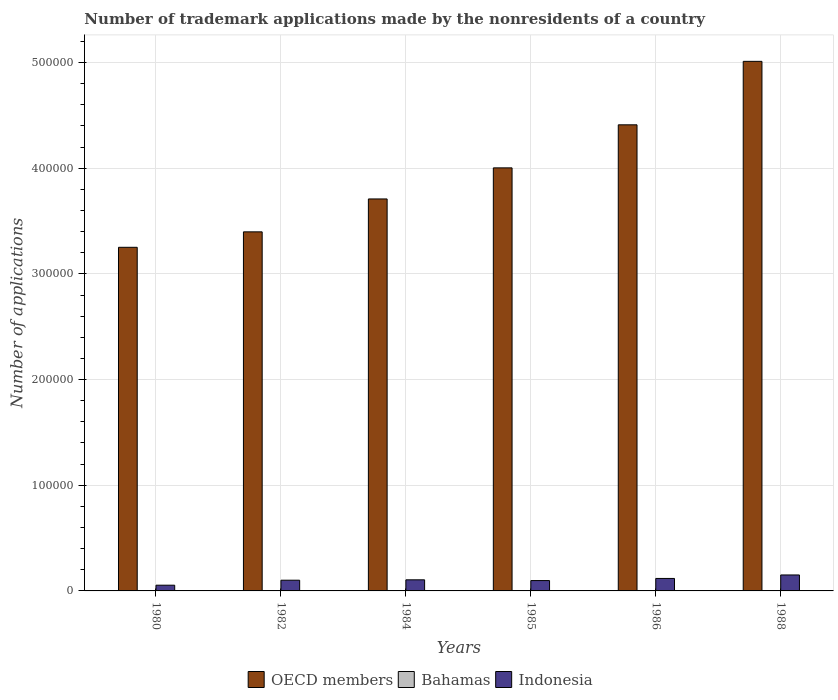How many groups of bars are there?
Your response must be concise. 6. Are the number of bars on each tick of the X-axis equal?
Offer a very short reply. Yes. In how many cases, is the number of bars for a given year not equal to the number of legend labels?
Your response must be concise. 0. What is the number of trademark applications made by the nonresidents in Indonesia in 1985?
Offer a very short reply. 9802. Across all years, what is the maximum number of trademark applications made by the nonresidents in OECD members?
Ensure brevity in your answer.  5.01e+05. Across all years, what is the minimum number of trademark applications made by the nonresidents in OECD members?
Provide a succinct answer. 3.25e+05. In which year was the number of trademark applications made by the nonresidents in Bahamas minimum?
Provide a short and direct response. 1980. What is the total number of trademark applications made by the nonresidents in Bahamas in the graph?
Your response must be concise. 249. What is the difference between the number of trademark applications made by the nonresidents in Indonesia in 1984 and that in 1988?
Offer a very short reply. -4599. What is the difference between the number of trademark applications made by the nonresidents in Indonesia in 1986 and the number of trademark applications made by the nonresidents in Bahamas in 1988?
Your answer should be compact. 1.17e+04. What is the average number of trademark applications made by the nonresidents in Bahamas per year?
Ensure brevity in your answer.  41.5. In the year 1982, what is the difference between the number of trademark applications made by the nonresidents in Bahamas and number of trademark applications made by the nonresidents in OECD members?
Offer a terse response. -3.40e+05. What is the ratio of the number of trademark applications made by the nonresidents in OECD members in 1982 to that in 1985?
Your answer should be compact. 0.85. Is the number of trademark applications made by the nonresidents in Indonesia in 1985 less than that in 1986?
Make the answer very short. Yes. Is the difference between the number of trademark applications made by the nonresidents in Bahamas in 1982 and 1984 greater than the difference between the number of trademark applications made by the nonresidents in OECD members in 1982 and 1984?
Provide a succinct answer. Yes. What is the difference between the highest and the second highest number of trademark applications made by the nonresidents in OECD members?
Ensure brevity in your answer.  6.01e+04. What is the difference between the highest and the lowest number of trademark applications made by the nonresidents in Bahamas?
Offer a very short reply. 50. In how many years, is the number of trademark applications made by the nonresidents in OECD members greater than the average number of trademark applications made by the nonresidents in OECD members taken over all years?
Make the answer very short. 3. What does the 1st bar from the left in 1982 represents?
Offer a terse response. OECD members. What does the 1st bar from the right in 1988 represents?
Keep it short and to the point. Indonesia. How many bars are there?
Your response must be concise. 18. How many years are there in the graph?
Provide a succinct answer. 6. Are the values on the major ticks of Y-axis written in scientific E-notation?
Make the answer very short. No. Where does the legend appear in the graph?
Your answer should be compact. Bottom center. What is the title of the graph?
Keep it short and to the point. Number of trademark applications made by the nonresidents of a country. Does "Haiti" appear as one of the legend labels in the graph?
Ensure brevity in your answer.  No. What is the label or title of the Y-axis?
Offer a very short reply. Number of applications. What is the Number of applications in OECD members in 1980?
Ensure brevity in your answer.  3.25e+05. What is the Number of applications in Bahamas in 1980?
Offer a terse response. 21. What is the Number of applications of Indonesia in 1980?
Your answer should be compact. 5425. What is the Number of applications in OECD members in 1982?
Provide a short and direct response. 3.40e+05. What is the Number of applications of Indonesia in 1982?
Offer a terse response. 1.01e+04. What is the Number of applications of OECD members in 1984?
Provide a short and direct response. 3.71e+05. What is the Number of applications of Indonesia in 1984?
Your answer should be very brief. 1.05e+04. What is the Number of applications of OECD members in 1985?
Provide a succinct answer. 4.00e+05. What is the Number of applications in Indonesia in 1985?
Your answer should be very brief. 9802. What is the Number of applications of OECD members in 1986?
Your answer should be compact. 4.41e+05. What is the Number of applications of Indonesia in 1986?
Provide a short and direct response. 1.18e+04. What is the Number of applications of OECD members in 1988?
Provide a succinct answer. 5.01e+05. What is the Number of applications in Indonesia in 1988?
Make the answer very short. 1.51e+04. Across all years, what is the maximum Number of applications of OECD members?
Offer a terse response. 5.01e+05. Across all years, what is the maximum Number of applications of Indonesia?
Your answer should be compact. 1.51e+04. Across all years, what is the minimum Number of applications in OECD members?
Offer a very short reply. 3.25e+05. Across all years, what is the minimum Number of applications of Indonesia?
Your response must be concise. 5425. What is the total Number of applications in OECD members in the graph?
Give a very brief answer. 2.38e+06. What is the total Number of applications of Bahamas in the graph?
Give a very brief answer. 249. What is the total Number of applications of Indonesia in the graph?
Your answer should be very brief. 6.28e+04. What is the difference between the Number of applications in OECD members in 1980 and that in 1982?
Offer a very short reply. -1.46e+04. What is the difference between the Number of applications in Indonesia in 1980 and that in 1982?
Keep it short and to the point. -4704. What is the difference between the Number of applications in OECD members in 1980 and that in 1984?
Offer a terse response. -4.58e+04. What is the difference between the Number of applications in Indonesia in 1980 and that in 1984?
Ensure brevity in your answer.  -5085. What is the difference between the Number of applications of OECD members in 1980 and that in 1985?
Ensure brevity in your answer.  -7.52e+04. What is the difference between the Number of applications in Indonesia in 1980 and that in 1985?
Offer a terse response. -4377. What is the difference between the Number of applications in OECD members in 1980 and that in 1986?
Keep it short and to the point. -1.16e+05. What is the difference between the Number of applications of Bahamas in 1980 and that in 1986?
Provide a succinct answer. -39. What is the difference between the Number of applications of Indonesia in 1980 and that in 1986?
Make the answer very short. -6382. What is the difference between the Number of applications in OECD members in 1980 and that in 1988?
Keep it short and to the point. -1.76e+05. What is the difference between the Number of applications in Bahamas in 1980 and that in 1988?
Your response must be concise. -50. What is the difference between the Number of applications of Indonesia in 1980 and that in 1988?
Give a very brief answer. -9684. What is the difference between the Number of applications in OECD members in 1982 and that in 1984?
Your answer should be very brief. -3.11e+04. What is the difference between the Number of applications of Bahamas in 1982 and that in 1984?
Your response must be concise. 9. What is the difference between the Number of applications of Indonesia in 1982 and that in 1984?
Make the answer very short. -381. What is the difference between the Number of applications of OECD members in 1982 and that in 1985?
Your response must be concise. -6.06e+04. What is the difference between the Number of applications of Indonesia in 1982 and that in 1985?
Your answer should be compact. 327. What is the difference between the Number of applications of OECD members in 1982 and that in 1986?
Offer a terse response. -1.01e+05. What is the difference between the Number of applications of Bahamas in 1982 and that in 1986?
Provide a succinct answer. -27. What is the difference between the Number of applications of Indonesia in 1982 and that in 1986?
Your response must be concise. -1678. What is the difference between the Number of applications in OECD members in 1982 and that in 1988?
Offer a terse response. -1.61e+05. What is the difference between the Number of applications of Bahamas in 1982 and that in 1988?
Ensure brevity in your answer.  -38. What is the difference between the Number of applications in Indonesia in 1982 and that in 1988?
Give a very brief answer. -4980. What is the difference between the Number of applications in OECD members in 1984 and that in 1985?
Provide a short and direct response. -2.94e+04. What is the difference between the Number of applications of Indonesia in 1984 and that in 1985?
Offer a very short reply. 708. What is the difference between the Number of applications in OECD members in 1984 and that in 1986?
Your answer should be compact. -7.02e+04. What is the difference between the Number of applications of Bahamas in 1984 and that in 1986?
Offer a terse response. -36. What is the difference between the Number of applications of Indonesia in 1984 and that in 1986?
Your response must be concise. -1297. What is the difference between the Number of applications of OECD members in 1984 and that in 1988?
Keep it short and to the point. -1.30e+05. What is the difference between the Number of applications in Bahamas in 1984 and that in 1988?
Your answer should be very brief. -47. What is the difference between the Number of applications in Indonesia in 1984 and that in 1988?
Offer a very short reply. -4599. What is the difference between the Number of applications in OECD members in 1985 and that in 1986?
Give a very brief answer. -4.07e+04. What is the difference between the Number of applications of Indonesia in 1985 and that in 1986?
Offer a terse response. -2005. What is the difference between the Number of applications of OECD members in 1985 and that in 1988?
Make the answer very short. -1.01e+05. What is the difference between the Number of applications in Bahamas in 1985 and that in 1988?
Provide a short and direct response. -31. What is the difference between the Number of applications of Indonesia in 1985 and that in 1988?
Ensure brevity in your answer.  -5307. What is the difference between the Number of applications of OECD members in 1986 and that in 1988?
Give a very brief answer. -6.01e+04. What is the difference between the Number of applications in Bahamas in 1986 and that in 1988?
Give a very brief answer. -11. What is the difference between the Number of applications of Indonesia in 1986 and that in 1988?
Keep it short and to the point. -3302. What is the difference between the Number of applications in OECD members in 1980 and the Number of applications in Bahamas in 1982?
Give a very brief answer. 3.25e+05. What is the difference between the Number of applications of OECD members in 1980 and the Number of applications of Indonesia in 1982?
Ensure brevity in your answer.  3.15e+05. What is the difference between the Number of applications in Bahamas in 1980 and the Number of applications in Indonesia in 1982?
Give a very brief answer. -1.01e+04. What is the difference between the Number of applications of OECD members in 1980 and the Number of applications of Bahamas in 1984?
Your answer should be very brief. 3.25e+05. What is the difference between the Number of applications in OECD members in 1980 and the Number of applications in Indonesia in 1984?
Your answer should be very brief. 3.15e+05. What is the difference between the Number of applications of Bahamas in 1980 and the Number of applications of Indonesia in 1984?
Your answer should be very brief. -1.05e+04. What is the difference between the Number of applications in OECD members in 1980 and the Number of applications in Bahamas in 1985?
Offer a very short reply. 3.25e+05. What is the difference between the Number of applications in OECD members in 1980 and the Number of applications in Indonesia in 1985?
Your answer should be compact. 3.15e+05. What is the difference between the Number of applications of Bahamas in 1980 and the Number of applications of Indonesia in 1985?
Ensure brevity in your answer.  -9781. What is the difference between the Number of applications of OECD members in 1980 and the Number of applications of Bahamas in 1986?
Provide a succinct answer. 3.25e+05. What is the difference between the Number of applications of OECD members in 1980 and the Number of applications of Indonesia in 1986?
Offer a very short reply. 3.13e+05. What is the difference between the Number of applications of Bahamas in 1980 and the Number of applications of Indonesia in 1986?
Make the answer very short. -1.18e+04. What is the difference between the Number of applications in OECD members in 1980 and the Number of applications in Bahamas in 1988?
Provide a succinct answer. 3.25e+05. What is the difference between the Number of applications in OECD members in 1980 and the Number of applications in Indonesia in 1988?
Offer a very short reply. 3.10e+05. What is the difference between the Number of applications of Bahamas in 1980 and the Number of applications of Indonesia in 1988?
Offer a terse response. -1.51e+04. What is the difference between the Number of applications in OECD members in 1982 and the Number of applications in Bahamas in 1984?
Give a very brief answer. 3.40e+05. What is the difference between the Number of applications in OECD members in 1982 and the Number of applications in Indonesia in 1984?
Offer a terse response. 3.29e+05. What is the difference between the Number of applications of Bahamas in 1982 and the Number of applications of Indonesia in 1984?
Offer a very short reply. -1.05e+04. What is the difference between the Number of applications in OECD members in 1982 and the Number of applications in Bahamas in 1985?
Your answer should be compact. 3.40e+05. What is the difference between the Number of applications in OECD members in 1982 and the Number of applications in Indonesia in 1985?
Your answer should be very brief. 3.30e+05. What is the difference between the Number of applications in Bahamas in 1982 and the Number of applications in Indonesia in 1985?
Keep it short and to the point. -9769. What is the difference between the Number of applications of OECD members in 1982 and the Number of applications of Bahamas in 1986?
Provide a succinct answer. 3.40e+05. What is the difference between the Number of applications of OECD members in 1982 and the Number of applications of Indonesia in 1986?
Provide a succinct answer. 3.28e+05. What is the difference between the Number of applications in Bahamas in 1982 and the Number of applications in Indonesia in 1986?
Provide a short and direct response. -1.18e+04. What is the difference between the Number of applications in OECD members in 1982 and the Number of applications in Bahamas in 1988?
Offer a terse response. 3.40e+05. What is the difference between the Number of applications of OECD members in 1982 and the Number of applications of Indonesia in 1988?
Provide a succinct answer. 3.25e+05. What is the difference between the Number of applications in Bahamas in 1982 and the Number of applications in Indonesia in 1988?
Ensure brevity in your answer.  -1.51e+04. What is the difference between the Number of applications of OECD members in 1984 and the Number of applications of Bahamas in 1985?
Give a very brief answer. 3.71e+05. What is the difference between the Number of applications of OECD members in 1984 and the Number of applications of Indonesia in 1985?
Provide a short and direct response. 3.61e+05. What is the difference between the Number of applications of Bahamas in 1984 and the Number of applications of Indonesia in 1985?
Provide a short and direct response. -9778. What is the difference between the Number of applications in OECD members in 1984 and the Number of applications in Bahamas in 1986?
Your answer should be very brief. 3.71e+05. What is the difference between the Number of applications of OECD members in 1984 and the Number of applications of Indonesia in 1986?
Offer a terse response. 3.59e+05. What is the difference between the Number of applications of Bahamas in 1984 and the Number of applications of Indonesia in 1986?
Your answer should be compact. -1.18e+04. What is the difference between the Number of applications of OECD members in 1984 and the Number of applications of Bahamas in 1988?
Ensure brevity in your answer.  3.71e+05. What is the difference between the Number of applications of OECD members in 1984 and the Number of applications of Indonesia in 1988?
Offer a very short reply. 3.56e+05. What is the difference between the Number of applications of Bahamas in 1984 and the Number of applications of Indonesia in 1988?
Offer a very short reply. -1.51e+04. What is the difference between the Number of applications in OECD members in 1985 and the Number of applications in Bahamas in 1986?
Provide a short and direct response. 4.00e+05. What is the difference between the Number of applications in OECD members in 1985 and the Number of applications in Indonesia in 1986?
Make the answer very short. 3.89e+05. What is the difference between the Number of applications of Bahamas in 1985 and the Number of applications of Indonesia in 1986?
Your answer should be very brief. -1.18e+04. What is the difference between the Number of applications of OECD members in 1985 and the Number of applications of Bahamas in 1988?
Provide a short and direct response. 4.00e+05. What is the difference between the Number of applications of OECD members in 1985 and the Number of applications of Indonesia in 1988?
Keep it short and to the point. 3.85e+05. What is the difference between the Number of applications in Bahamas in 1985 and the Number of applications in Indonesia in 1988?
Make the answer very short. -1.51e+04. What is the difference between the Number of applications in OECD members in 1986 and the Number of applications in Bahamas in 1988?
Your answer should be very brief. 4.41e+05. What is the difference between the Number of applications in OECD members in 1986 and the Number of applications in Indonesia in 1988?
Offer a terse response. 4.26e+05. What is the difference between the Number of applications of Bahamas in 1986 and the Number of applications of Indonesia in 1988?
Offer a very short reply. -1.50e+04. What is the average Number of applications in OECD members per year?
Offer a terse response. 3.96e+05. What is the average Number of applications of Bahamas per year?
Your answer should be compact. 41.5. What is the average Number of applications in Indonesia per year?
Offer a terse response. 1.05e+04. In the year 1980, what is the difference between the Number of applications of OECD members and Number of applications of Bahamas?
Give a very brief answer. 3.25e+05. In the year 1980, what is the difference between the Number of applications of OECD members and Number of applications of Indonesia?
Provide a short and direct response. 3.20e+05. In the year 1980, what is the difference between the Number of applications in Bahamas and Number of applications in Indonesia?
Provide a short and direct response. -5404. In the year 1982, what is the difference between the Number of applications of OECD members and Number of applications of Bahamas?
Make the answer very short. 3.40e+05. In the year 1982, what is the difference between the Number of applications of OECD members and Number of applications of Indonesia?
Give a very brief answer. 3.30e+05. In the year 1982, what is the difference between the Number of applications of Bahamas and Number of applications of Indonesia?
Your response must be concise. -1.01e+04. In the year 1984, what is the difference between the Number of applications of OECD members and Number of applications of Bahamas?
Keep it short and to the point. 3.71e+05. In the year 1984, what is the difference between the Number of applications of OECD members and Number of applications of Indonesia?
Provide a short and direct response. 3.60e+05. In the year 1984, what is the difference between the Number of applications in Bahamas and Number of applications in Indonesia?
Your response must be concise. -1.05e+04. In the year 1985, what is the difference between the Number of applications of OECD members and Number of applications of Bahamas?
Keep it short and to the point. 4.00e+05. In the year 1985, what is the difference between the Number of applications in OECD members and Number of applications in Indonesia?
Your answer should be compact. 3.91e+05. In the year 1985, what is the difference between the Number of applications in Bahamas and Number of applications in Indonesia?
Provide a short and direct response. -9762. In the year 1986, what is the difference between the Number of applications of OECD members and Number of applications of Bahamas?
Give a very brief answer. 4.41e+05. In the year 1986, what is the difference between the Number of applications in OECD members and Number of applications in Indonesia?
Provide a short and direct response. 4.29e+05. In the year 1986, what is the difference between the Number of applications in Bahamas and Number of applications in Indonesia?
Offer a very short reply. -1.17e+04. In the year 1988, what is the difference between the Number of applications of OECD members and Number of applications of Bahamas?
Provide a short and direct response. 5.01e+05. In the year 1988, what is the difference between the Number of applications in OECD members and Number of applications in Indonesia?
Keep it short and to the point. 4.86e+05. In the year 1988, what is the difference between the Number of applications in Bahamas and Number of applications in Indonesia?
Offer a very short reply. -1.50e+04. What is the ratio of the Number of applications in OECD members in 1980 to that in 1982?
Keep it short and to the point. 0.96. What is the ratio of the Number of applications in Bahamas in 1980 to that in 1982?
Your answer should be compact. 0.64. What is the ratio of the Number of applications of Indonesia in 1980 to that in 1982?
Keep it short and to the point. 0.54. What is the ratio of the Number of applications in OECD members in 1980 to that in 1984?
Your answer should be compact. 0.88. What is the ratio of the Number of applications in Bahamas in 1980 to that in 1984?
Give a very brief answer. 0.88. What is the ratio of the Number of applications of Indonesia in 1980 to that in 1984?
Offer a very short reply. 0.52. What is the ratio of the Number of applications in OECD members in 1980 to that in 1985?
Ensure brevity in your answer.  0.81. What is the ratio of the Number of applications in Bahamas in 1980 to that in 1985?
Offer a terse response. 0.53. What is the ratio of the Number of applications of Indonesia in 1980 to that in 1985?
Offer a very short reply. 0.55. What is the ratio of the Number of applications of OECD members in 1980 to that in 1986?
Provide a short and direct response. 0.74. What is the ratio of the Number of applications in Bahamas in 1980 to that in 1986?
Keep it short and to the point. 0.35. What is the ratio of the Number of applications in Indonesia in 1980 to that in 1986?
Provide a succinct answer. 0.46. What is the ratio of the Number of applications in OECD members in 1980 to that in 1988?
Provide a short and direct response. 0.65. What is the ratio of the Number of applications in Bahamas in 1980 to that in 1988?
Provide a short and direct response. 0.3. What is the ratio of the Number of applications in Indonesia in 1980 to that in 1988?
Give a very brief answer. 0.36. What is the ratio of the Number of applications of OECD members in 1982 to that in 1984?
Provide a succinct answer. 0.92. What is the ratio of the Number of applications in Bahamas in 1982 to that in 1984?
Keep it short and to the point. 1.38. What is the ratio of the Number of applications of Indonesia in 1982 to that in 1984?
Give a very brief answer. 0.96. What is the ratio of the Number of applications of OECD members in 1982 to that in 1985?
Provide a short and direct response. 0.85. What is the ratio of the Number of applications in Bahamas in 1982 to that in 1985?
Provide a succinct answer. 0.82. What is the ratio of the Number of applications in Indonesia in 1982 to that in 1985?
Offer a very short reply. 1.03. What is the ratio of the Number of applications of OECD members in 1982 to that in 1986?
Keep it short and to the point. 0.77. What is the ratio of the Number of applications in Bahamas in 1982 to that in 1986?
Keep it short and to the point. 0.55. What is the ratio of the Number of applications in Indonesia in 1982 to that in 1986?
Provide a short and direct response. 0.86. What is the ratio of the Number of applications of OECD members in 1982 to that in 1988?
Offer a very short reply. 0.68. What is the ratio of the Number of applications in Bahamas in 1982 to that in 1988?
Ensure brevity in your answer.  0.46. What is the ratio of the Number of applications of Indonesia in 1982 to that in 1988?
Your answer should be compact. 0.67. What is the ratio of the Number of applications in OECD members in 1984 to that in 1985?
Provide a succinct answer. 0.93. What is the ratio of the Number of applications in Bahamas in 1984 to that in 1985?
Make the answer very short. 0.6. What is the ratio of the Number of applications of Indonesia in 1984 to that in 1985?
Your response must be concise. 1.07. What is the ratio of the Number of applications of OECD members in 1984 to that in 1986?
Ensure brevity in your answer.  0.84. What is the ratio of the Number of applications of Indonesia in 1984 to that in 1986?
Provide a succinct answer. 0.89. What is the ratio of the Number of applications of OECD members in 1984 to that in 1988?
Your answer should be compact. 0.74. What is the ratio of the Number of applications of Bahamas in 1984 to that in 1988?
Offer a very short reply. 0.34. What is the ratio of the Number of applications in Indonesia in 1984 to that in 1988?
Your response must be concise. 0.7. What is the ratio of the Number of applications in OECD members in 1985 to that in 1986?
Your answer should be compact. 0.91. What is the ratio of the Number of applications of Indonesia in 1985 to that in 1986?
Your answer should be compact. 0.83. What is the ratio of the Number of applications of OECD members in 1985 to that in 1988?
Offer a terse response. 0.8. What is the ratio of the Number of applications in Bahamas in 1985 to that in 1988?
Keep it short and to the point. 0.56. What is the ratio of the Number of applications in Indonesia in 1985 to that in 1988?
Provide a short and direct response. 0.65. What is the ratio of the Number of applications of OECD members in 1986 to that in 1988?
Your answer should be very brief. 0.88. What is the ratio of the Number of applications of Bahamas in 1986 to that in 1988?
Ensure brevity in your answer.  0.85. What is the ratio of the Number of applications in Indonesia in 1986 to that in 1988?
Offer a terse response. 0.78. What is the difference between the highest and the second highest Number of applications in OECD members?
Your answer should be very brief. 6.01e+04. What is the difference between the highest and the second highest Number of applications of Bahamas?
Your answer should be very brief. 11. What is the difference between the highest and the second highest Number of applications of Indonesia?
Offer a terse response. 3302. What is the difference between the highest and the lowest Number of applications in OECD members?
Ensure brevity in your answer.  1.76e+05. What is the difference between the highest and the lowest Number of applications of Bahamas?
Keep it short and to the point. 50. What is the difference between the highest and the lowest Number of applications in Indonesia?
Offer a very short reply. 9684. 